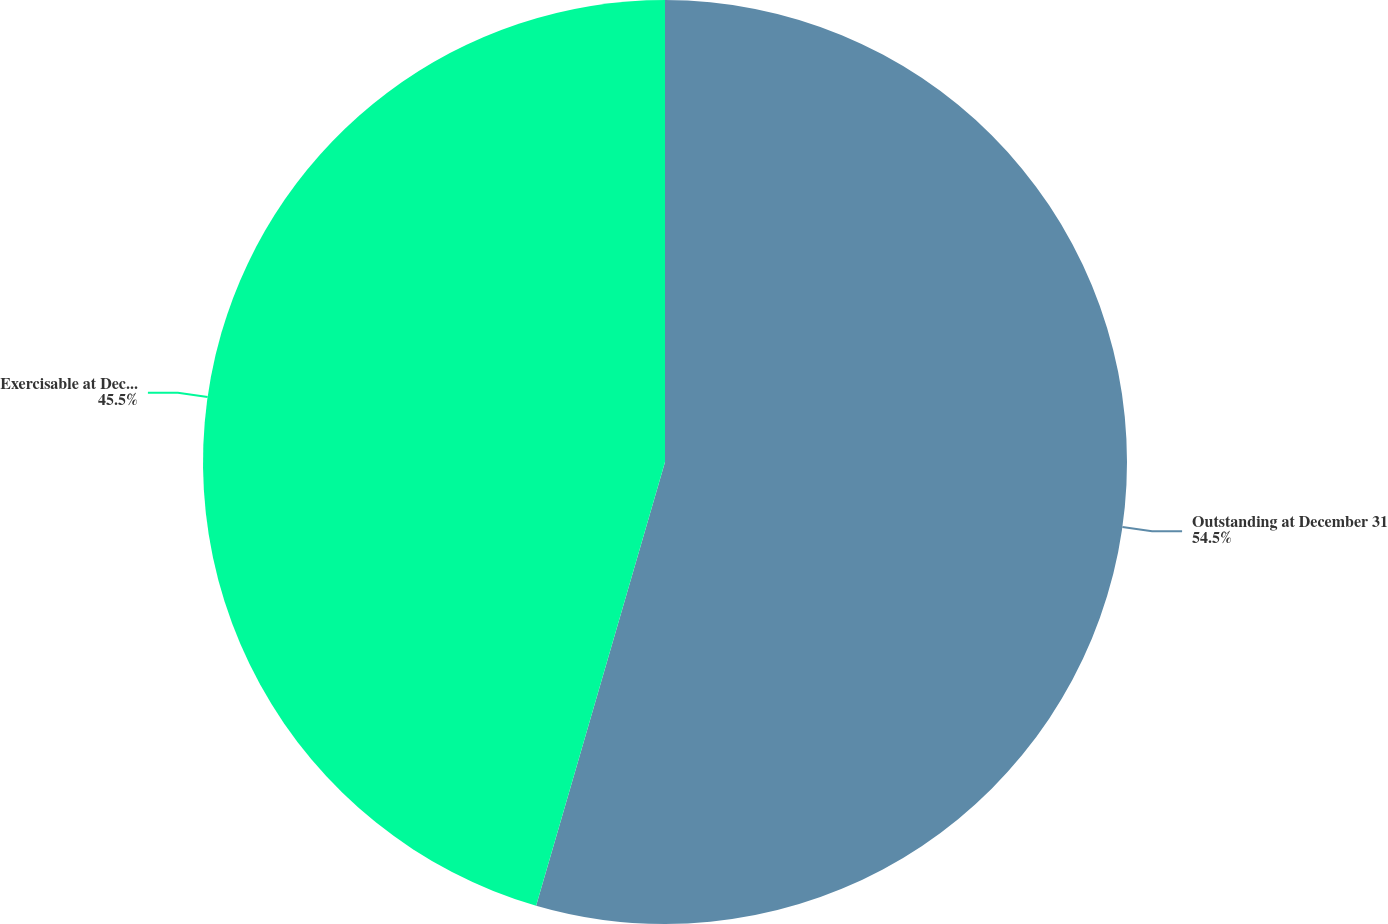Convert chart. <chart><loc_0><loc_0><loc_500><loc_500><pie_chart><fcel>Outstanding at December 31<fcel>Exercisable at December 31<nl><fcel>54.5%<fcel>45.5%<nl></chart> 